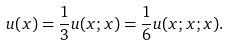<formula> <loc_0><loc_0><loc_500><loc_500>u ( x ) = \frac { 1 } { 3 } u ( x ; x ) = \frac { 1 } { 6 } u ( x ; x ; x ) .</formula> 